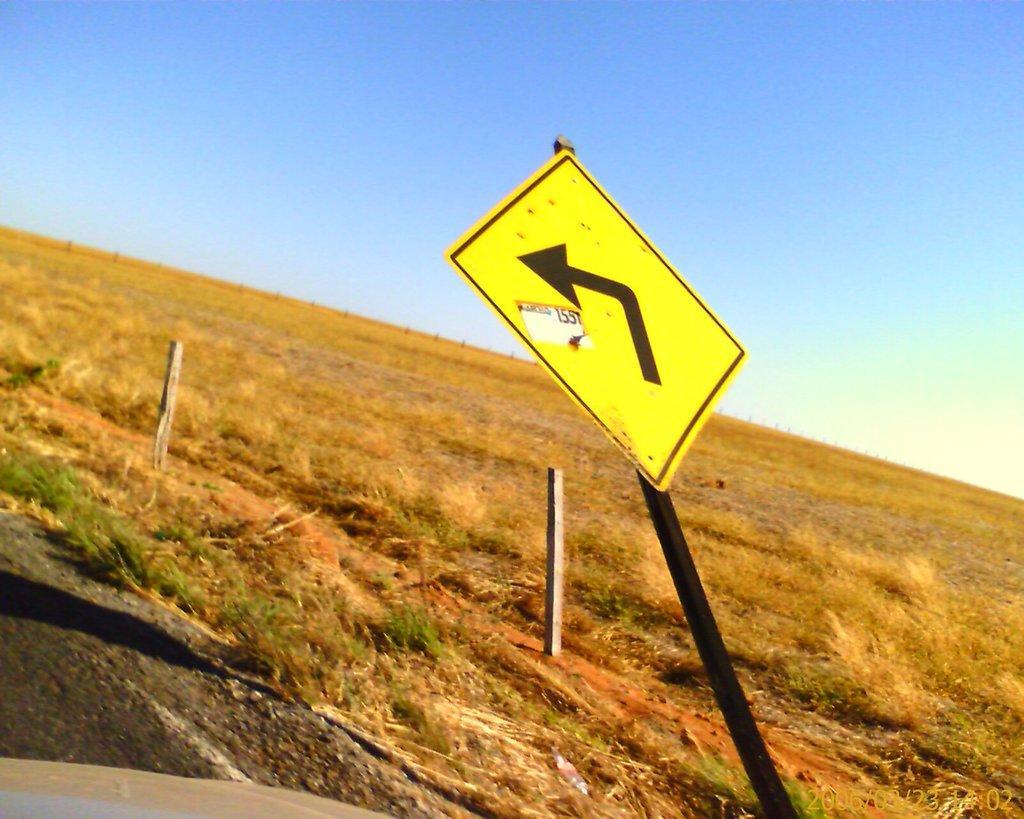Could you give a brief overview of what you see in this image? In the image in the center we can see the poles and one sign board. In the background we can see the sky,fence and grass. 